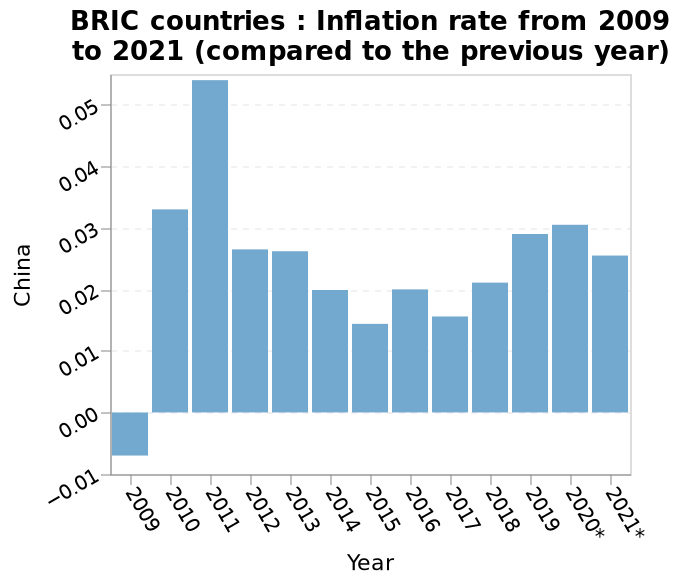<image>
please describe the details of the chart Here a is a bar plot labeled BRIC countries : Inflation rate from 2009 to 2021 (compared to the previous year). The y-axis plots China using categorical scale from −0.01 to 0.05 while the x-axis shows Year using categorical scale from 2009 to 2021*. What is the range of the y-axis on the bar plot? The range of the y-axis on the bar plot is from -0.01 to 0.05. please summary the statistics and relations of the chart Since 2009, when there was a fall in inflation, China has experienced consistent positive inflation year on year, reaching a peak in 2011 at over 0.05, mostly falling between 0.01 and 0.03. What does the x-axis of the bar plot represent? The x-axis of the bar plot represents the Year. 